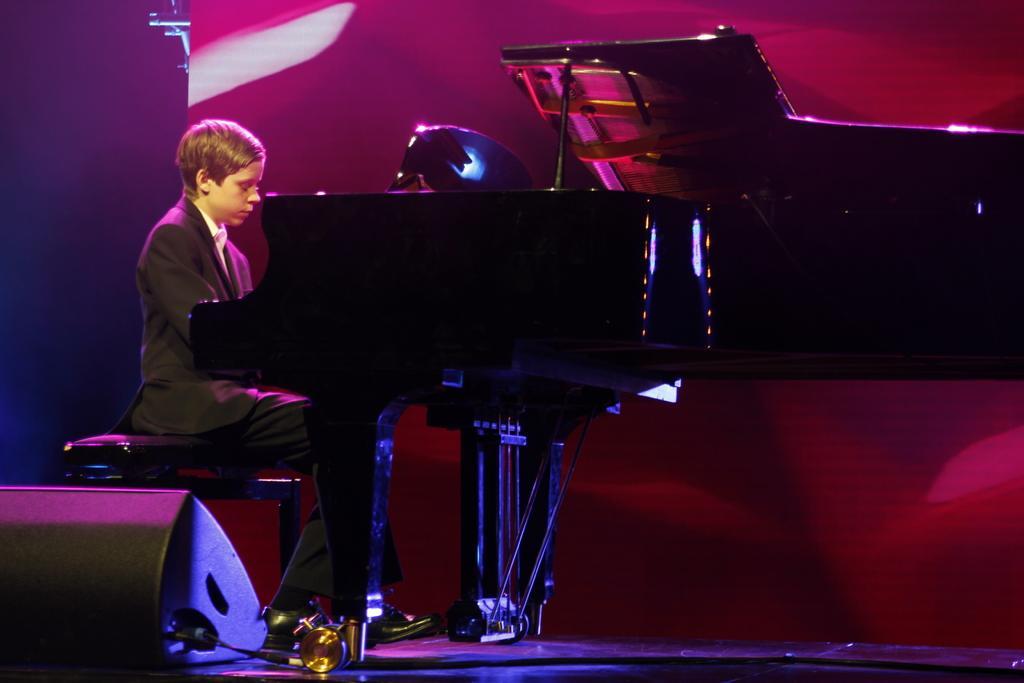How would you summarize this image in a sentence or two? In the image we can see that a boy is sitting on a chair and playing piano. He is wearing blazer and shoes. 